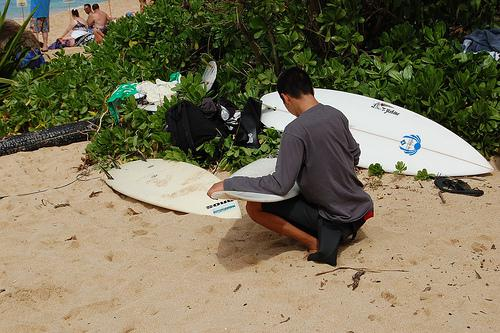Question: what is the man's feet touching?
Choices:
A. Floor.
B. Water.
C. Grass.
D. Sand.
Answer with the letter. Answer: D Question: who is wearing a gray shirt?
Choices:
A. The man.
B. Woman.
C. Boy.
D. Waiter.
Answer with the letter. Answer: A Question: what color shorts is the man wearing?
Choices:
A. Black.
B. Blue.
C. Brown.
D. Grey.
Answer with the letter. Answer: A Question: what color is the man's hair?
Choices:
A. Brown.
B. Grey.
C. Black.
D. Blonde.
Answer with the letter. Answer: C 